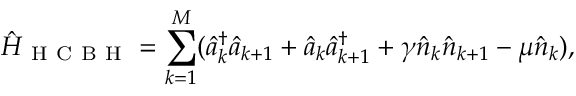Convert formula to latex. <formula><loc_0><loc_0><loc_500><loc_500>\hat { H } _ { H C B H } = \sum _ { k = 1 } ^ { M } ( \hat { a } _ { k } ^ { \dag } \hat { a } _ { k + 1 } + \hat { a } _ { k } \hat { a } _ { k + 1 } ^ { \dag } + \gamma \hat { n } _ { k } \hat { n } _ { k + 1 } - \mu \hat { n } _ { k } ) ,</formula> 